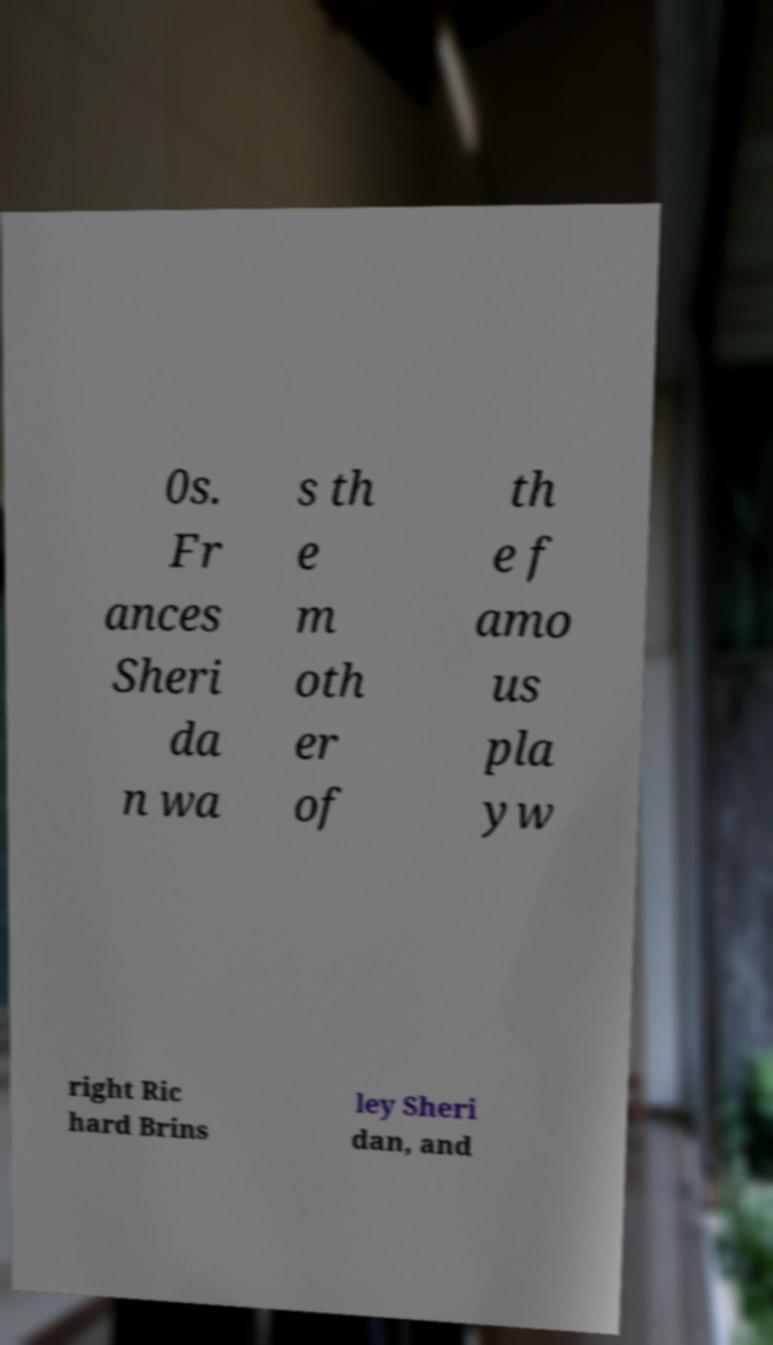I need the written content from this picture converted into text. Can you do that? 0s. Fr ances Sheri da n wa s th e m oth er of th e f amo us pla yw right Ric hard Brins ley Sheri dan, and 